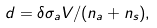Convert formula to latex. <formula><loc_0><loc_0><loc_500><loc_500>d = \delta \sigma _ { a } V / ( n _ { a } + n _ { s } ) ,</formula> 